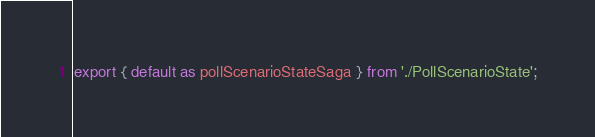Convert code to text. <code><loc_0><loc_0><loc_500><loc_500><_JavaScript_>export { default as pollScenarioStateSaga } from './PollScenarioState';
</code> 